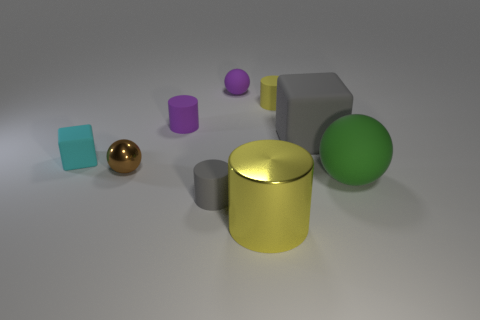Add 1 blue matte objects. How many objects exist? 10 Subtract all cylinders. How many objects are left? 5 Subtract all big cyan rubber spheres. Subtract all yellow metallic cylinders. How many objects are left? 8 Add 6 large gray things. How many large gray things are left? 7 Add 1 matte things. How many matte things exist? 8 Subtract 0 gray spheres. How many objects are left? 9 